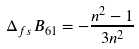<formula> <loc_0><loc_0><loc_500><loc_500>\Delta _ { f s } B _ { \mathrm 6 1 } = - \frac { n ^ { 2 } - 1 } { 3 n ^ { 2 } }</formula> 